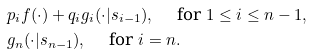Convert formula to latex. <formula><loc_0><loc_0><loc_500><loc_500>& p _ { i } f ( \cdot ) + q _ { i } g _ { i } ( \cdot | s _ { i - 1 } ) , \quad \text { for } 1 \leq i \leq n - 1 , \\ & g _ { n } ( \cdot | s _ { n - 1 } ) , \quad \text { for } i = n .</formula> 